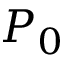Convert formula to latex. <formula><loc_0><loc_0><loc_500><loc_500>P _ { 0 }</formula> 